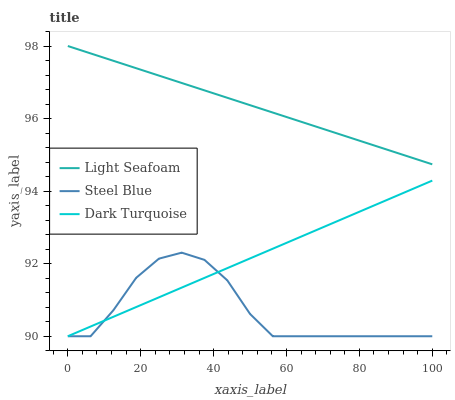Does Steel Blue have the minimum area under the curve?
Answer yes or no. Yes. Does Light Seafoam have the maximum area under the curve?
Answer yes or no. Yes. Does Light Seafoam have the minimum area under the curve?
Answer yes or no. No. Does Steel Blue have the maximum area under the curve?
Answer yes or no. No. Is Light Seafoam the smoothest?
Answer yes or no. Yes. Is Steel Blue the roughest?
Answer yes or no. Yes. Is Steel Blue the smoothest?
Answer yes or no. No. Is Light Seafoam the roughest?
Answer yes or no. No. Does Dark Turquoise have the lowest value?
Answer yes or no. Yes. Does Light Seafoam have the lowest value?
Answer yes or no. No. Does Light Seafoam have the highest value?
Answer yes or no. Yes. Does Steel Blue have the highest value?
Answer yes or no. No. Is Steel Blue less than Light Seafoam?
Answer yes or no. Yes. Is Light Seafoam greater than Dark Turquoise?
Answer yes or no. Yes. Does Dark Turquoise intersect Steel Blue?
Answer yes or no. Yes. Is Dark Turquoise less than Steel Blue?
Answer yes or no. No. Is Dark Turquoise greater than Steel Blue?
Answer yes or no. No. Does Steel Blue intersect Light Seafoam?
Answer yes or no. No. 